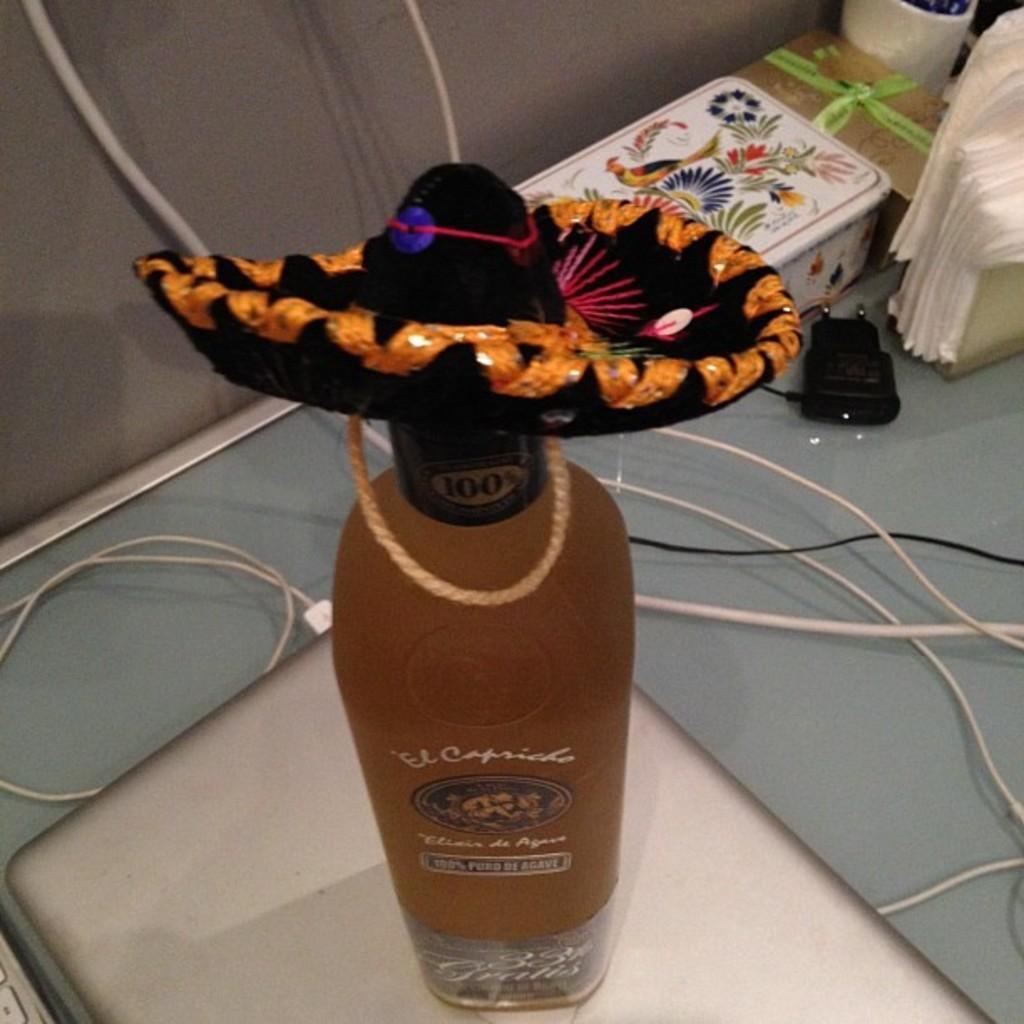How would you summarize this image in a sentence or two? In this image there is a bottle which is placed on the laptop and on the bottle there is a hat and in the background there are some books. 